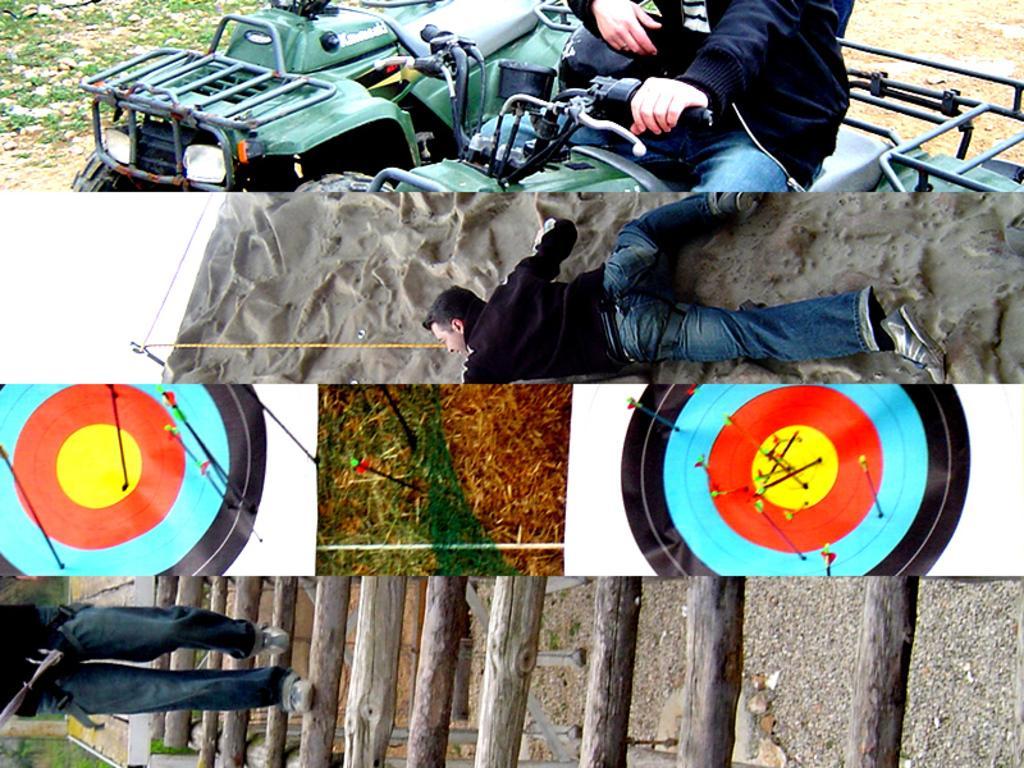In one or two sentences, can you explain what this image depicts? In this image we can see collage images, in those images we can see three persons, vehicle, rocks, grass, rope, wall, archery targets, arrows, wooden staircase, also we can see the sky. 